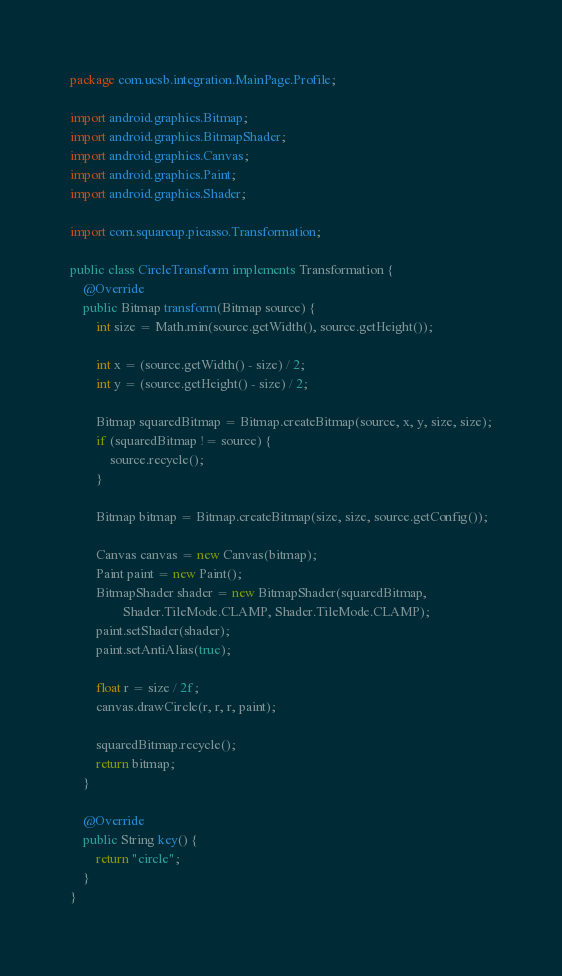<code> <loc_0><loc_0><loc_500><loc_500><_Java_>package com.ucsb.integration.MainPage.Profile;

import android.graphics.Bitmap;
import android.graphics.BitmapShader;
import android.graphics.Canvas;
import android.graphics.Paint;
import android.graphics.Shader;

import com.squareup.picasso.Transformation;

public class CircleTransform implements Transformation {
    @Override
    public Bitmap transform(Bitmap source) {
        int size = Math.min(source.getWidth(), source.getHeight());

        int x = (source.getWidth() - size) / 2;
        int y = (source.getHeight() - size) / 2;

        Bitmap squaredBitmap = Bitmap.createBitmap(source, x, y, size, size);
        if (squaredBitmap != source) {
            source.recycle();
        }

        Bitmap bitmap = Bitmap.createBitmap(size, size, source.getConfig());

        Canvas canvas = new Canvas(bitmap);
        Paint paint = new Paint();
        BitmapShader shader = new BitmapShader(squaredBitmap,
                Shader.TileMode.CLAMP, Shader.TileMode.CLAMP);
        paint.setShader(shader);
        paint.setAntiAlias(true);

        float r = size / 2f;
        canvas.drawCircle(r, r, r, paint);

        squaredBitmap.recycle();
        return bitmap;
    }

    @Override
    public String key() {
        return "circle";
    }
}</code> 